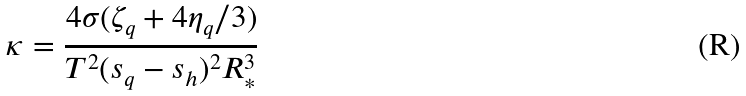Convert formula to latex. <formula><loc_0><loc_0><loc_500><loc_500>\kappa = \frac { 4 \sigma ( \zeta _ { q } + 4 \eta _ { q } / 3 ) } { T ^ { 2 } ( s _ { q } - s _ { h } ) ^ { 2 } R _ { * } ^ { 3 } }</formula> 